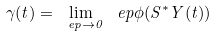Convert formula to latex. <formula><loc_0><loc_0><loc_500><loc_500>\gamma ( t ) = \lim _ { \ e p \to 0 } \ e p \phi ( S ^ { * } Y ( t ) )</formula> 